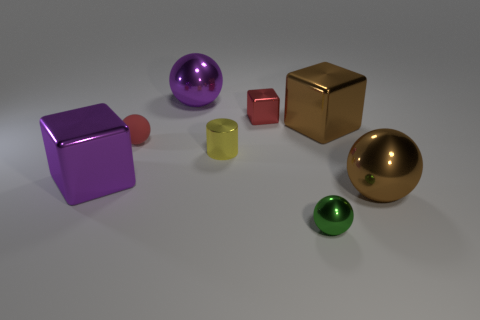Subtract all purple spheres. How many spheres are left? 3 Add 2 brown metallic balls. How many objects exist? 10 Subtract all cubes. How many objects are left? 5 Subtract all yellow balls. Subtract all brown blocks. How many balls are left? 4 Subtract all brown things. Subtract all red spheres. How many objects are left? 5 Add 6 yellow objects. How many yellow objects are left? 7 Add 4 cylinders. How many cylinders exist? 5 Subtract all brown balls. How many balls are left? 3 Subtract 0 red cylinders. How many objects are left? 8 Subtract 2 blocks. How many blocks are left? 1 